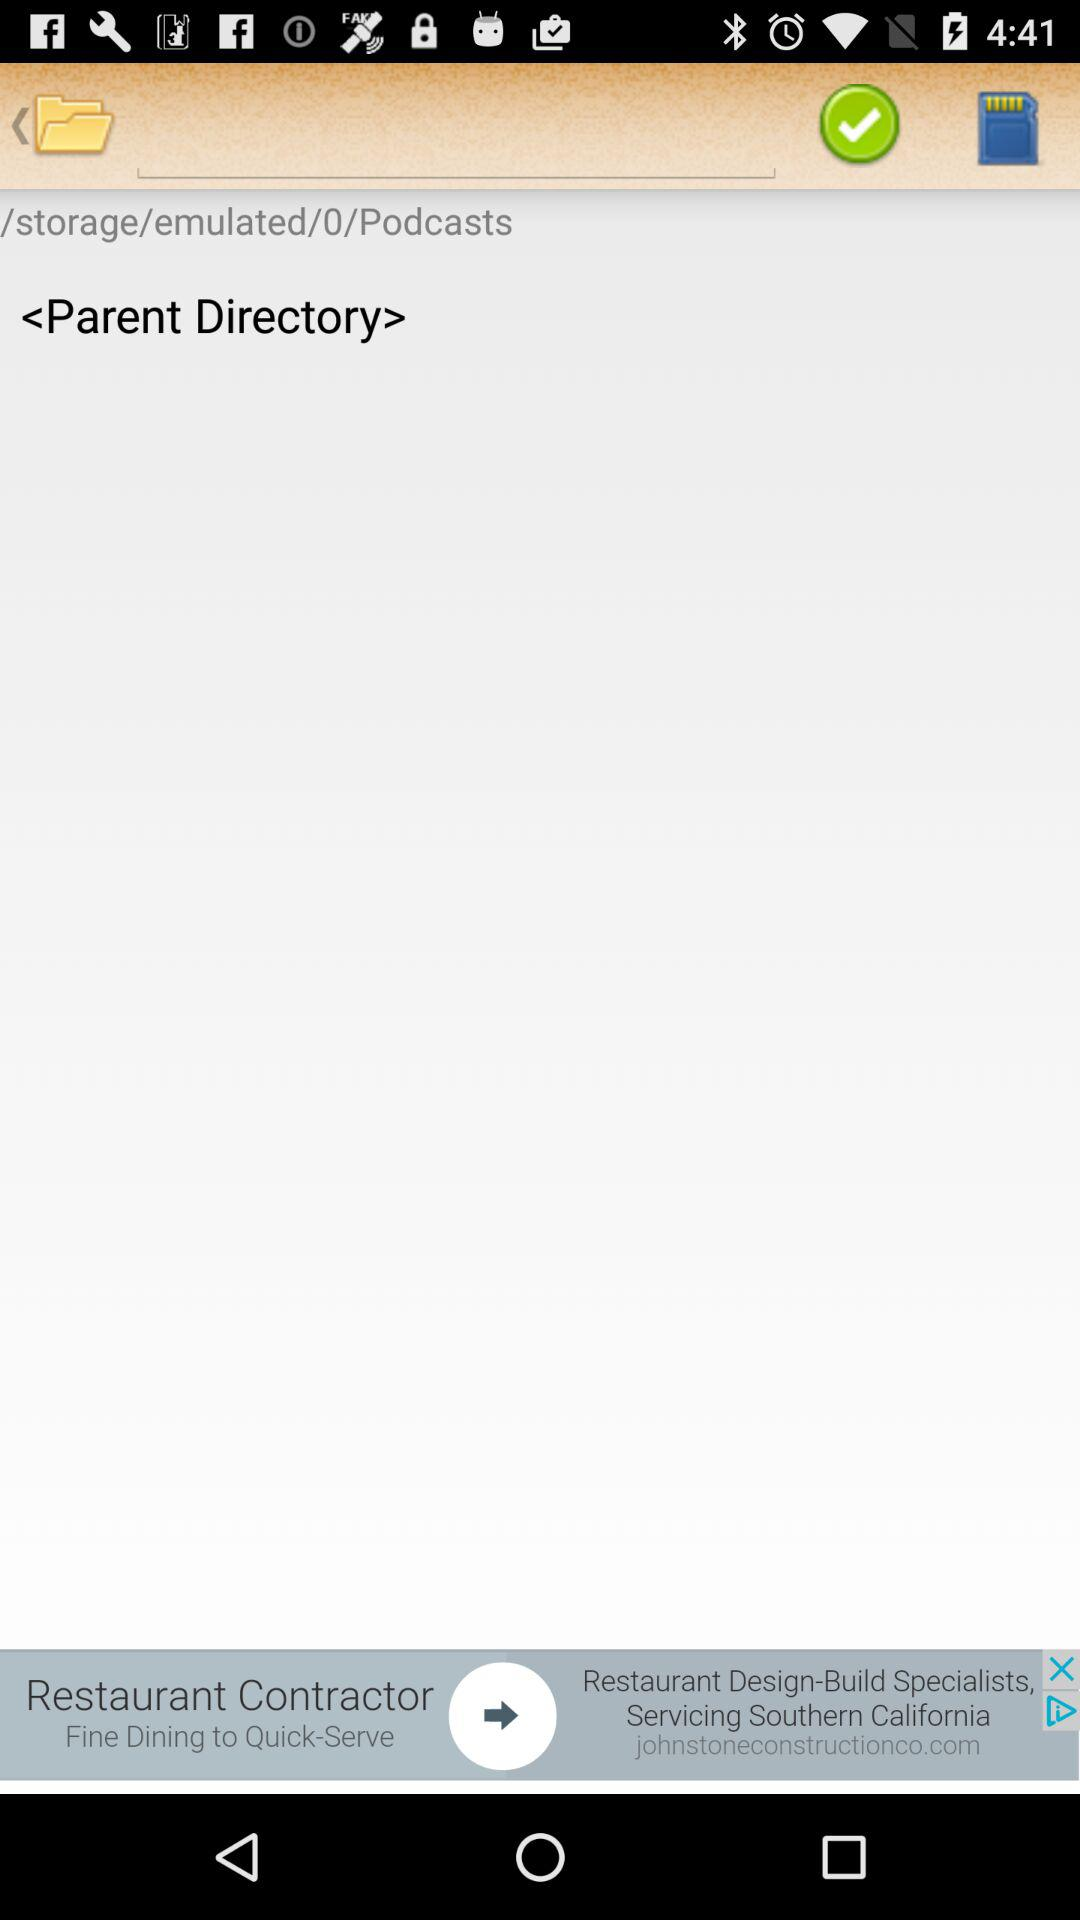If the current directory is /storage/emulated/0/Podcasts, what is the full path of the parent directory?
Answer the question using a single word or phrase. /storage/emulated/0 